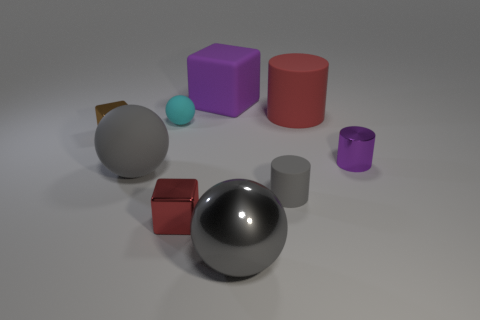Subtract all yellow spheres. Subtract all gray cylinders. How many spheres are left? 3 Subtract all cylinders. How many objects are left? 6 Subtract 0 yellow cylinders. How many objects are left? 9 Subtract all gray matte objects. Subtract all matte objects. How many objects are left? 2 Add 4 small blocks. How many small blocks are left? 6 Add 8 small purple cylinders. How many small purple cylinders exist? 9 